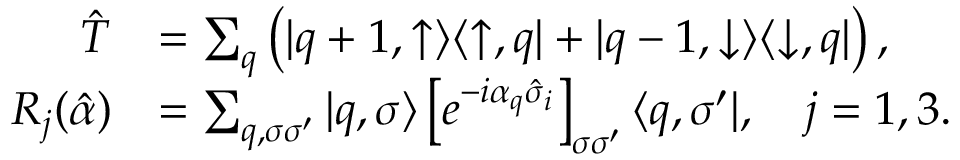Convert formula to latex. <formula><loc_0><loc_0><loc_500><loc_500>\begin{array} { r l } { \hat { T } } & { = \sum _ { q } \left ( | q + 1 , \uparrow \rangle \langle \uparrow , q | + | q - 1 , \downarrow \rangle \langle \downarrow , q | \right ) , } \\ { R _ { j } ( \hat { \alpha } ) } & { = \sum _ { q , \sigma \sigma ^ { \prime } } | q , \sigma \rangle \left [ e ^ { - i \alpha _ { q } \hat { \sigma } _ { i } } \right ] _ { \sigma \sigma ^ { \prime } } \langle q , \sigma ^ { \prime } | , \quad j = 1 , 3 . } \end{array}</formula> 